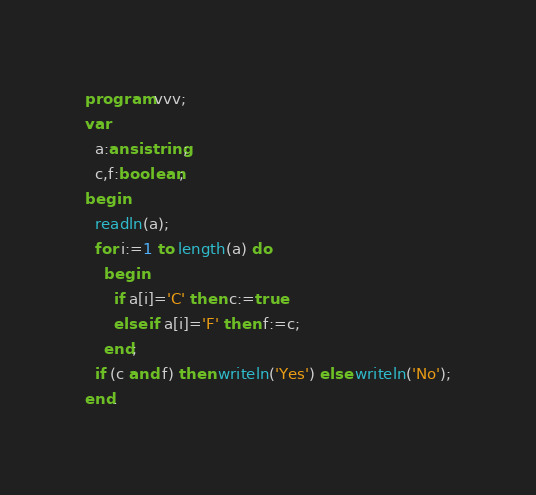<code> <loc_0><loc_0><loc_500><loc_500><_Pascal_>program vvv;
var
  a:ansistring;
  c,f:boolean;
begin
  readln(a);
  for i:=1 to length(a) do
    begin
      if a[i]='C' then c:=true
      else if a[i]='F' then f:=c;
    end;
  if (c and f) then writeln('Yes') else writeln('No');
end.</code> 